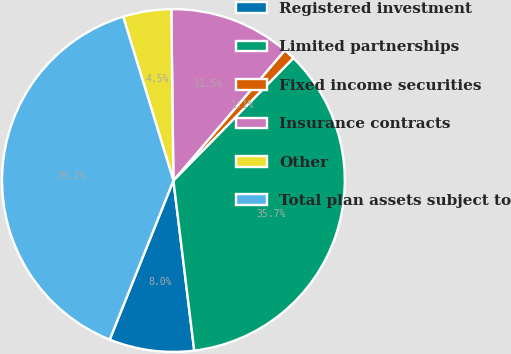Convert chart. <chart><loc_0><loc_0><loc_500><loc_500><pie_chart><fcel>Registered investment<fcel>Limited partnerships<fcel>Fixed income securities<fcel>Insurance contracts<fcel>Other<fcel>Total plan assets subject to<nl><fcel>8.0%<fcel>35.73%<fcel>1.07%<fcel>11.46%<fcel>4.54%<fcel>39.2%<nl></chart> 